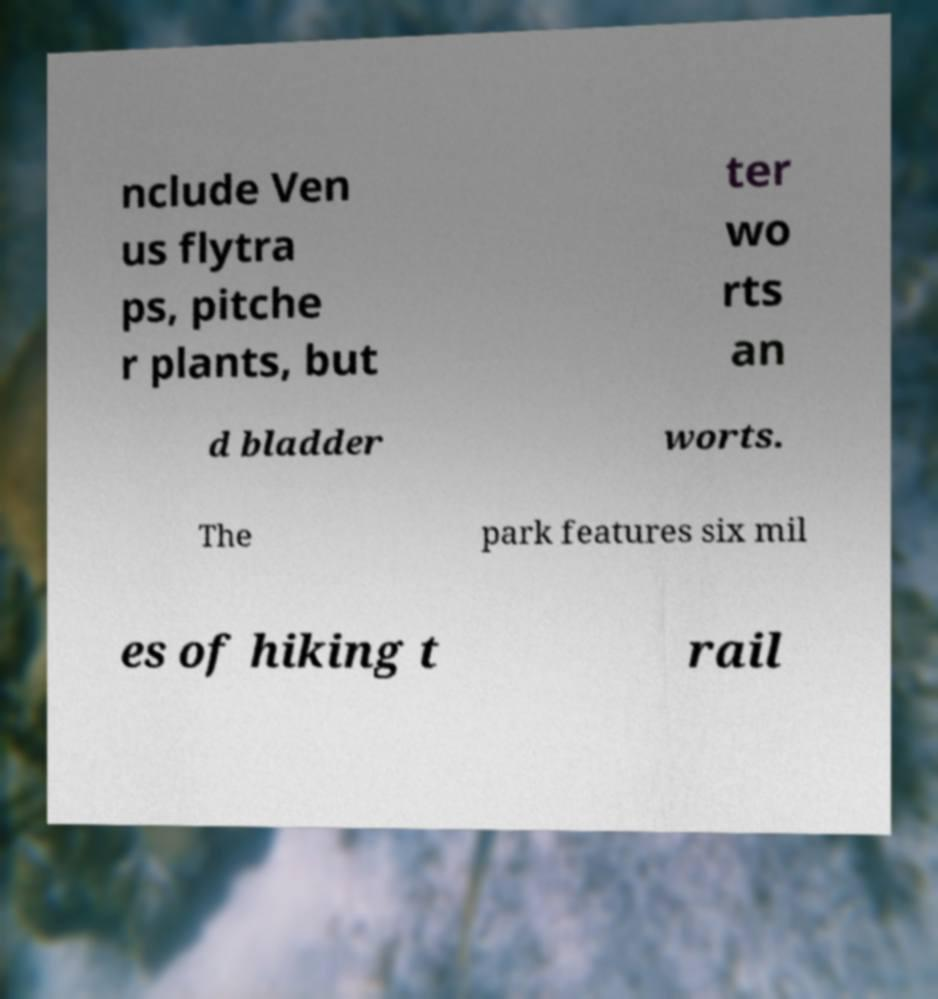For documentation purposes, I need the text within this image transcribed. Could you provide that? nclude Ven us flytra ps, pitche r plants, but ter wo rts an d bladder worts. The park features six mil es of hiking t rail 